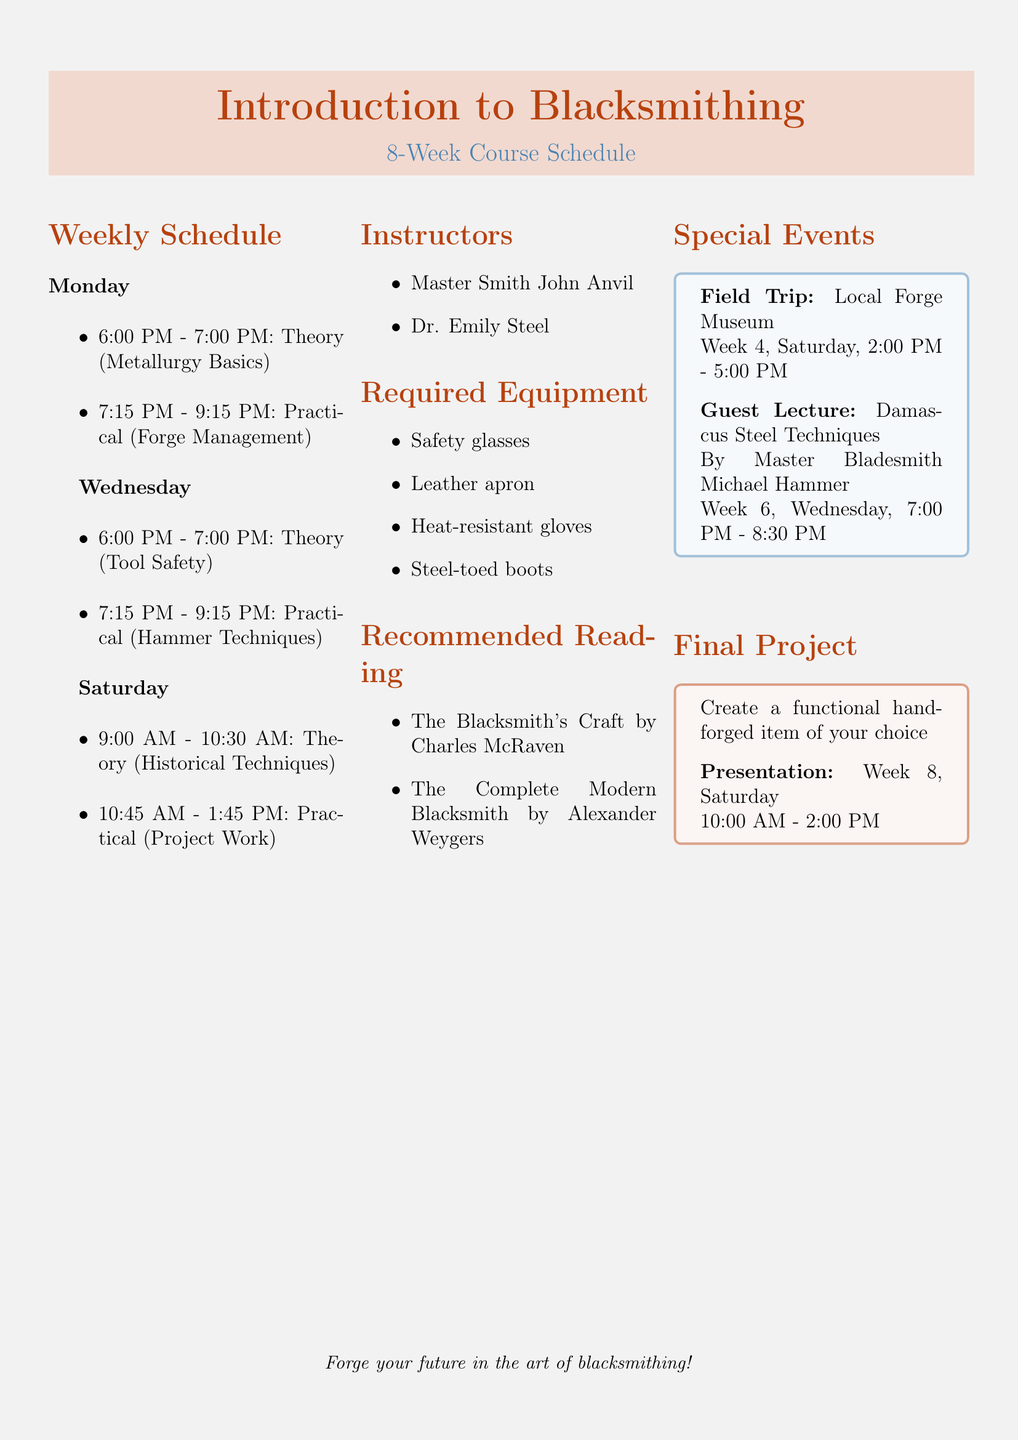What is the course name? The course name is explicitly stated in the document under the title section.
Answer: Introduction to Blacksmithing How long is the course duration? The document specifies the duration of the course at the beginning.
Answer: 8 weeks What is the first theory topic taught on Monday? The theory topic for Monday is listed in the schedule section.
Answer: Metallurgy Basics and Steel Properties When is the Field Trip scheduled? The date and time for the Field Trip to the Local Forge Museum is mentioned as a special event.
Answer: Week 4, Saturday, 2:00 PM - 5:00 PM Who is the instructor specializing in Traditional Forging Techniques? The names and specializations of the instructors are listed in the document.
Answer: Master Smith John Anvil What equipment is required for the course? The list of required equipment is found in the relevant section of the document.
Answer: Safety glasses, Leather apron, Heat-resistant gloves, Steel-toed boots What is the focus of the guest lecture in Week 6? The content of the guest lecture is specified in the special events section.
Answer: Damascus Steel Techniques What is the final project description? The final project details are mentioned towards the end of the document.
Answer: Create a functional hand-forged item of your choice What time does the practical session start on Wednesday? The start time for the practical session is stated in the weekly schedule.
Answer: 7:15 PM 